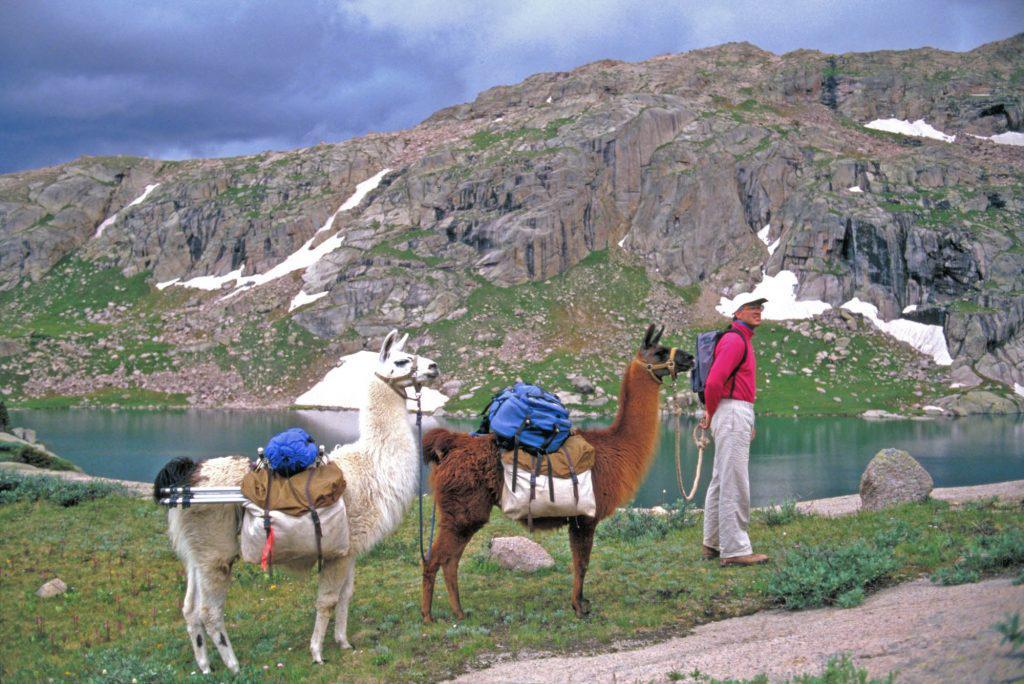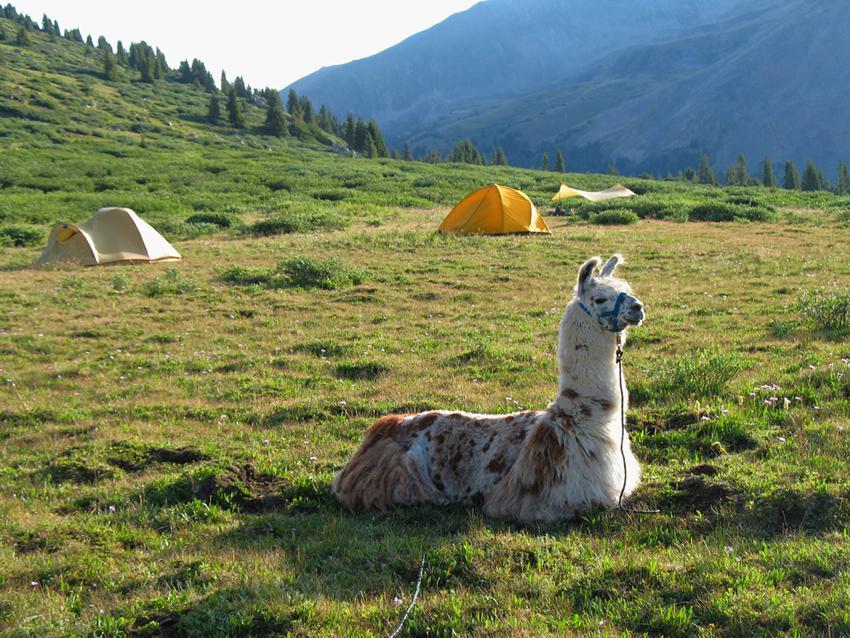The first image is the image on the left, the second image is the image on the right. For the images displayed, is the sentence "The llamas in the right image are carrying packs." factually correct? Answer yes or no. No. The first image is the image on the left, the second image is the image on the right. Assess this claim about the two images: "The right image shows multiple people standing near multiple llamas wearing packs and facing mountain peaks.". Correct or not? Answer yes or no. No. 